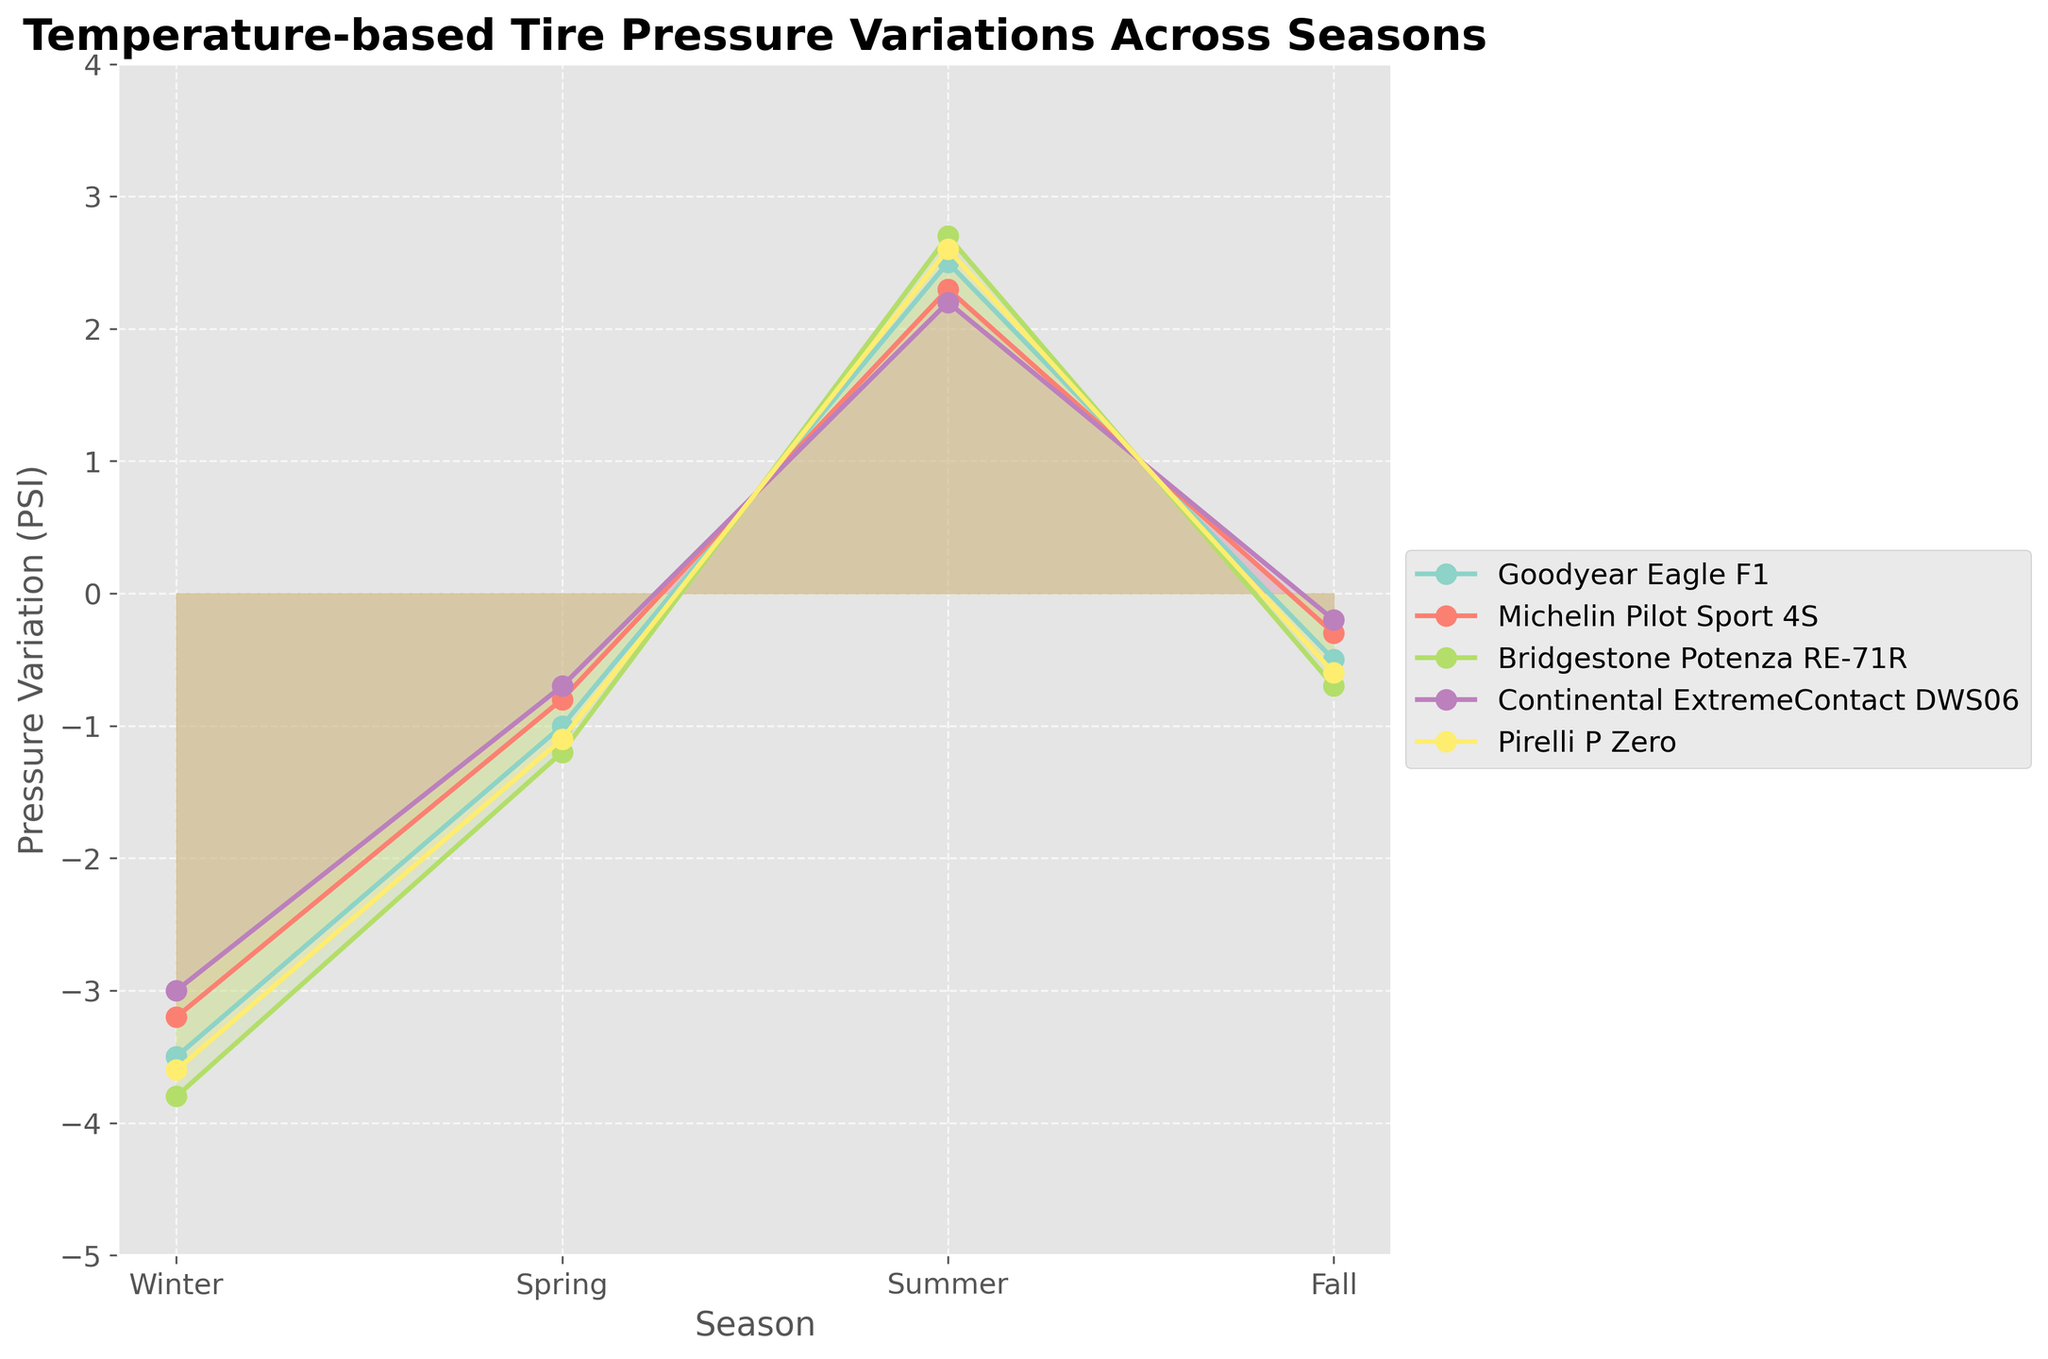What is the title of the figure? The title of a chart is typically displayed at the top and provides a summary of what the chart represents. In this case, the title tells us that the chart shows how tire pressure varies across different seasons.
Answer: Temperature-based Tire Pressure Variations Across Seasons How many seasons are shown in the figure? The x-axis of the chart displays the different seasons, and each season is represented as a distinct data point. By counting these data points, we can determine the number of seasons.
Answer: 4 Which tire brand shows the highest pressure variation in summer? To find the highest pressure variation, we look at the y-axis values for the summer data points of each tire brand. The highest point indicates the brand with the largest positive variation.
Answer: Bridgestone Potenza RE-71R What is the average tire pressure variation for Continental ExtremeContact DWS06 across all seasons? First, we need to add the pressure variations for Continental ExtremeContact DWS06 across all seasons: (-3.0) + (-0.7) + 2.2 + (-0.2). Then, divide by the number of seasons, which is 4.
Answer: -0.425 Which season shows the most negative tire pressure variation for Michelin Pilot Sport 4S? To find the most negative pressure variation, we examine the y-axis values for the Michelin Pilot Sport 4S across all seasons and identify the lowest value.
Answer: Winter Which two brands have the most similar pressure variations in winter? By comparing the pressure variations of each brand in winter, we look for the two brands with the closest y-axis values.
Answer: Goodyear Eagle F1 and Michelin Pilot Sport 4S Between Goodyear Eagle F1 and Pirelli P Zero, which brand has a smaller fluctuation in pressure variations between summer and winter? We calculate the fluctuation for each brand by subtracting the winter value from the summer value and compare the two results. Goodyear Eagle F1's fluctuation is 2.5 - (-3.5) = 6, and Pirelli P Zero's fluctuation is 2.6 - (-3.6) = 6.2.
Answer: Goodyear Eagle F1 What is the total range of pressure variations for Bridgestone Potenza RE-71R across all seasons? To find the range, we need the highest and lowest values of Bridgestone Potenza RE-71R across all seasons. The range is calculated by subtracting the lowest value from the highest value. Highest: 2.7, Lowest: -3.8, Range: 2.7 - (-3.8) = 6.5.
Answer: 6.5 Are there any brands that do not show a negative pressure variation in any of the seasons? We need to check the values for each brand across all four seasons. If a brand has only positive values, it means it doesn't show a negative variation. However, all brands shown have negative values in at least one season.
Answer: No Which tire brand has the largest increase in pressure variation when transitioning from winter to summer? To calculate the increase, subtract the winter values from the summer values for each brand. The brand with the highest positive difference has the largest increase. Differences: Goodyear Eagle F1 (2.5 - (-3.5) = 6), Michelin Pilot Sport 4S (2.3 - (-3.2) = 5.5), Bridgestone Potenza RE-71R (2.7 - (-3.8) = 6.5), Continental ExtremeContact DWS06 (2.2 - (-3.0) = 5.2), Pirelli P Zero (2.6 - (-3.6) = 6.2).
Answer: Bridgestone Potenza RE-71R 